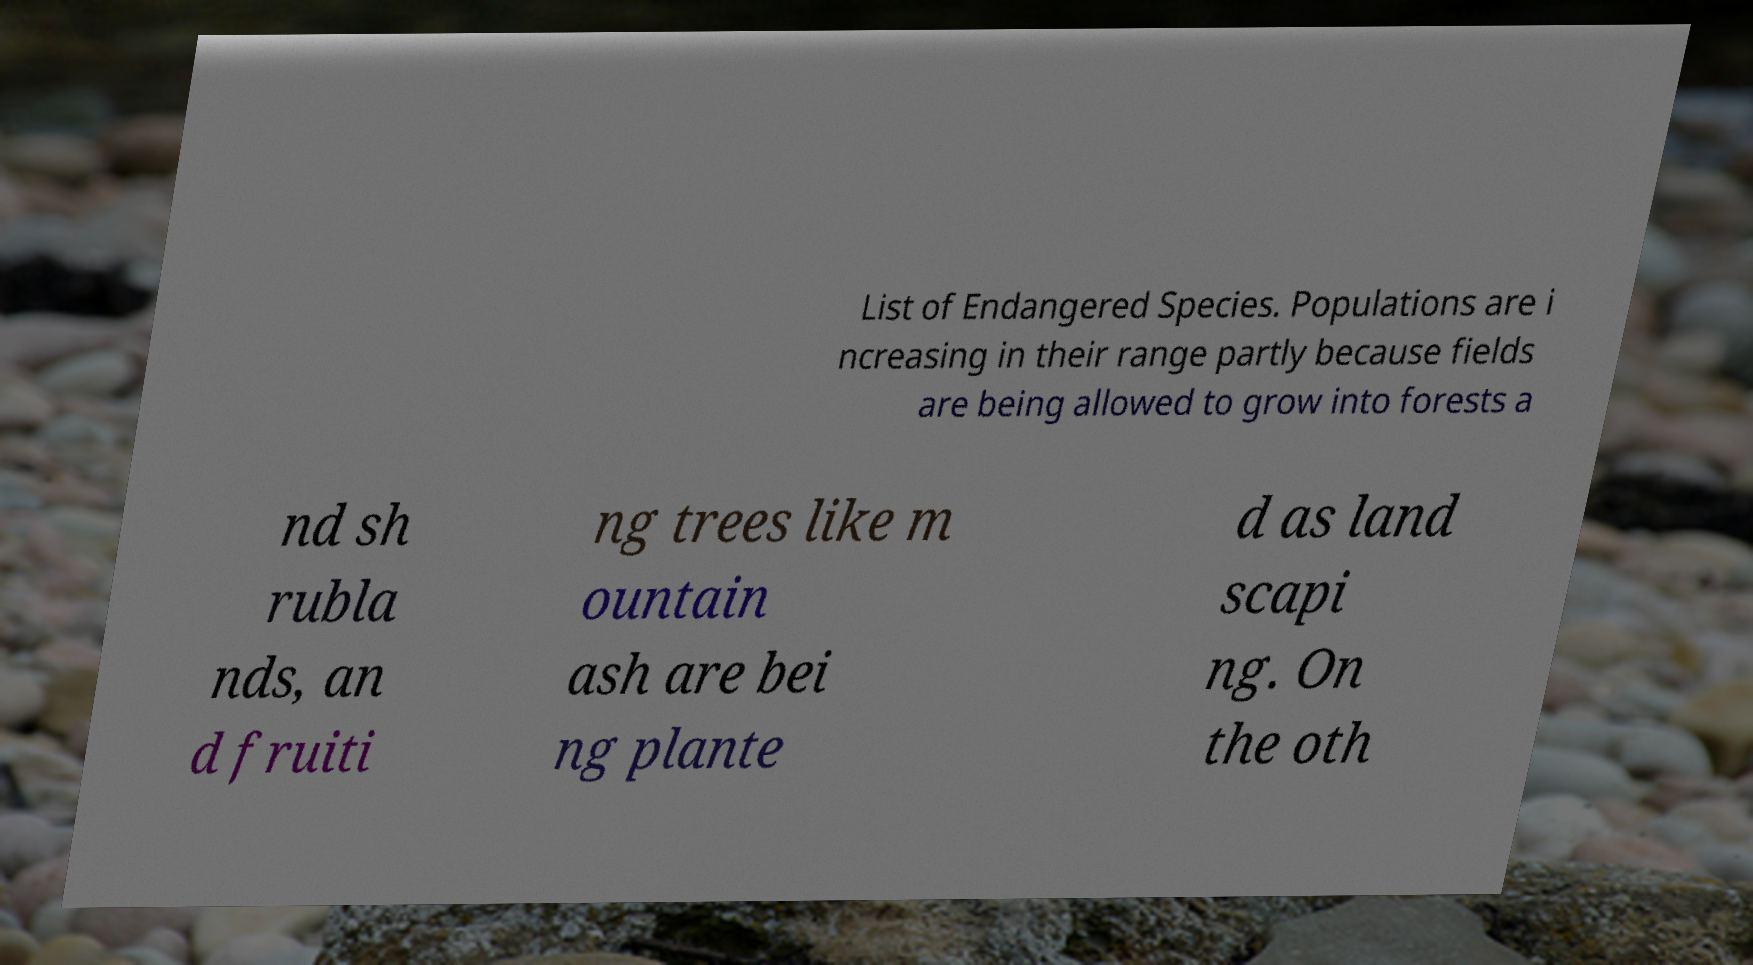There's text embedded in this image that I need extracted. Can you transcribe it verbatim? List of Endangered Species. Populations are i ncreasing in their range partly because fields are being allowed to grow into forests a nd sh rubla nds, an d fruiti ng trees like m ountain ash are bei ng plante d as land scapi ng. On the oth 